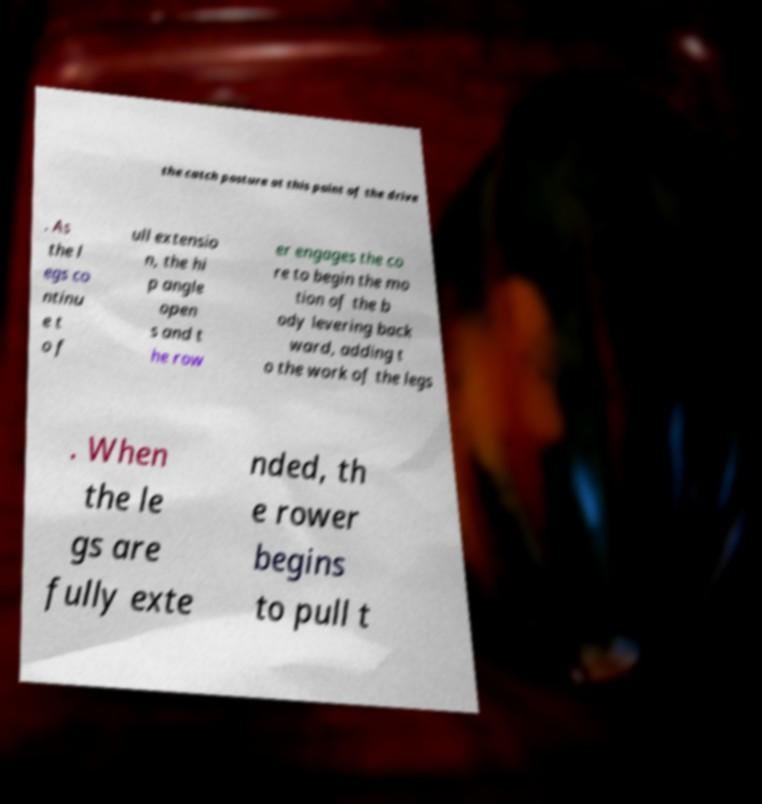Can you accurately transcribe the text from the provided image for me? the catch posture at this point of the drive . As the l egs co ntinu e t o f ull extensio n, the hi p angle open s and t he row er engages the co re to begin the mo tion of the b ody levering back ward, adding t o the work of the legs . When the le gs are fully exte nded, th e rower begins to pull t 